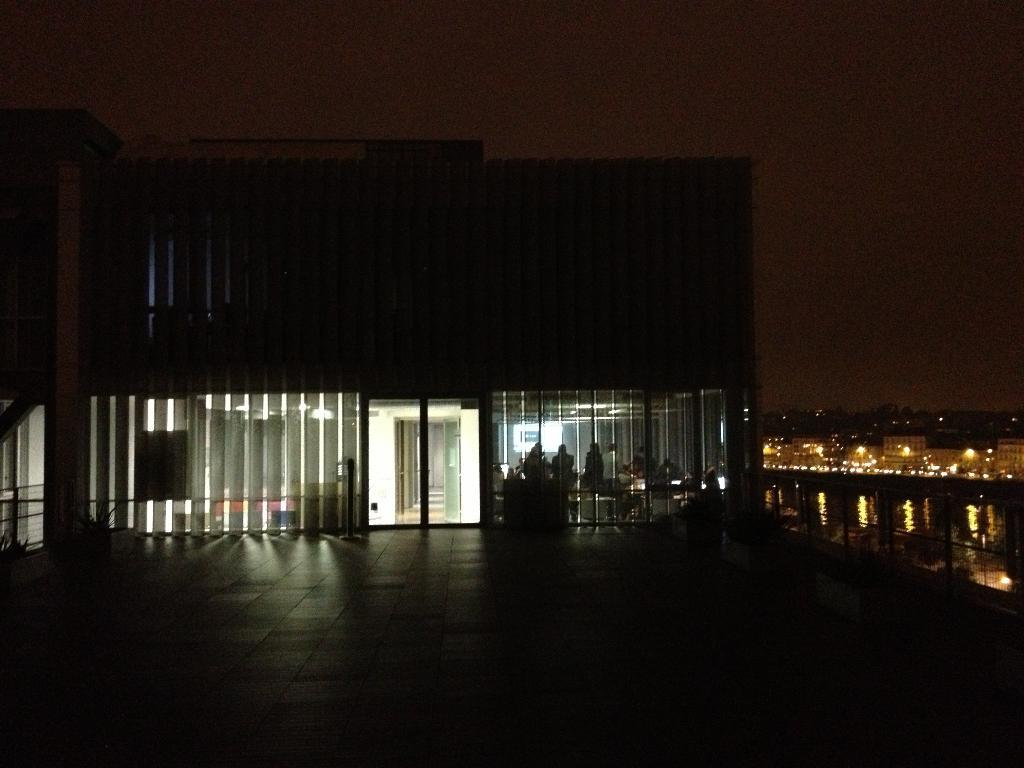What type of structures can be seen in the image? There are buildings in the image. Can you describe a specific feature of one of the buildings? There is a door visible in the image. What are the people in the image doing? The people in the image are sitting. What is visible at the top of the image? The sky is visible at the top of the image. What type of food is being served in the lunchroom in the image? There is no lunchroom present in the image. What position do the people sitting in the image hold? The image does not provide information about the positions held by the people sitting in the image. 